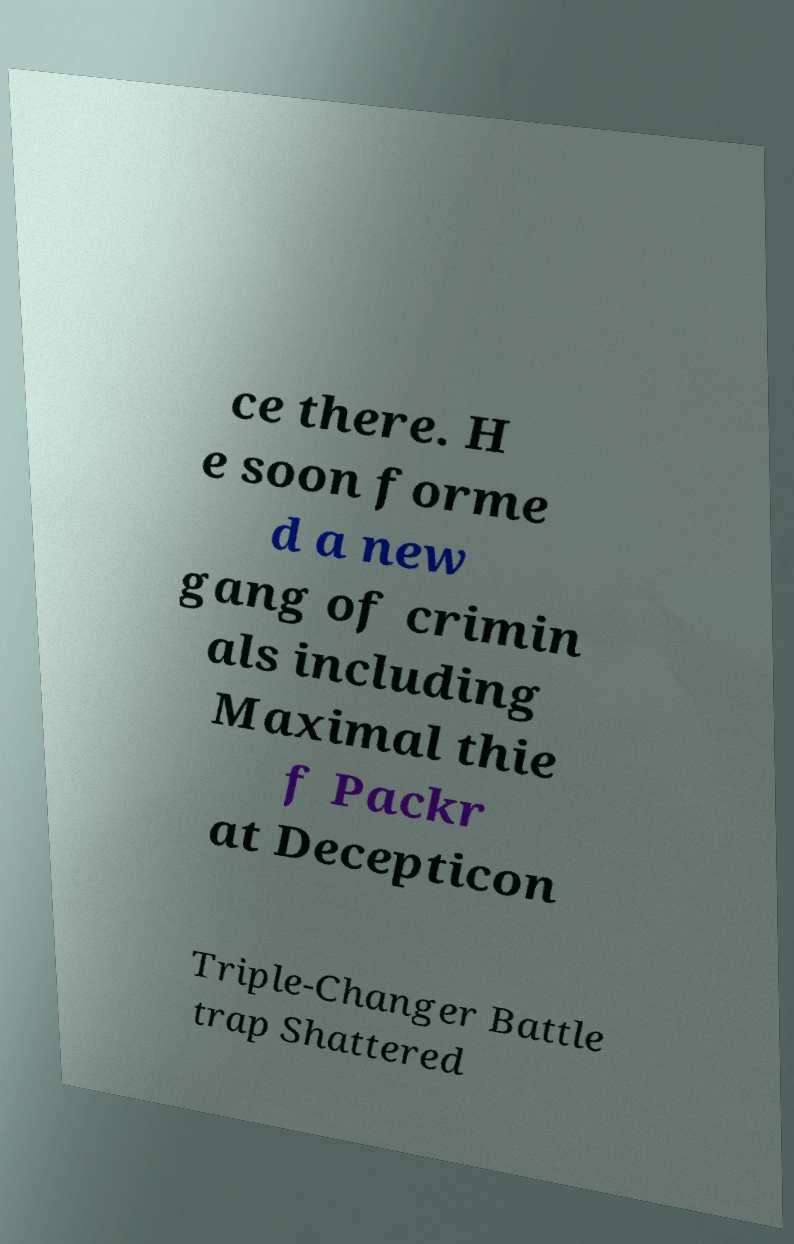I need the written content from this picture converted into text. Can you do that? ce there. H e soon forme d a new gang of crimin als including Maximal thie f Packr at Decepticon Triple-Changer Battle trap Shattered 